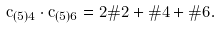Convert formula to latex. <formula><loc_0><loc_0><loc_500><loc_500>\bar { c } _ { ( { 5 } ) 4 } \cdot \bar { c } _ { ( { 5 } ) 6 } = 2 \# 2 + \# 4 + \# 6 .</formula> 